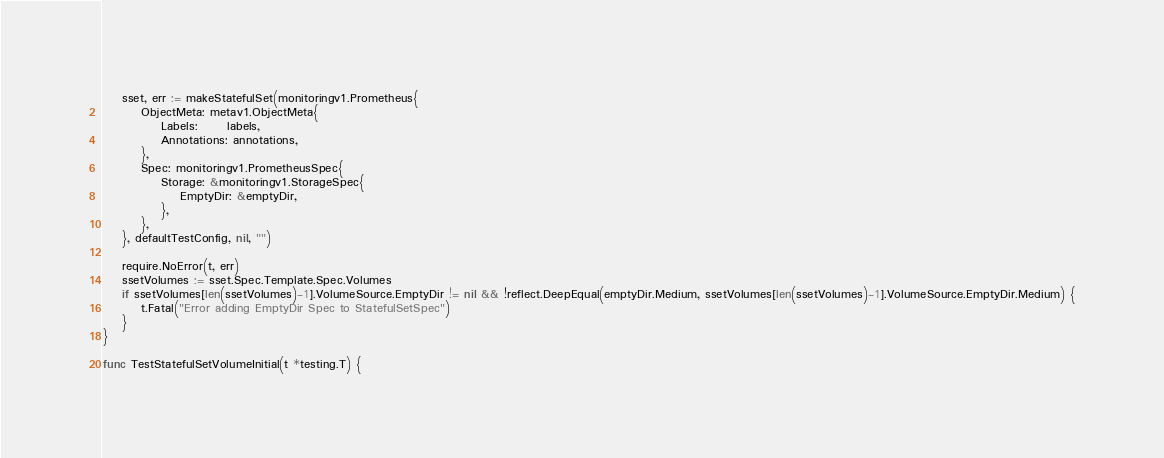Convert code to text. <code><loc_0><loc_0><loc_500><loc_500><_Go_>	sset, err := makeStatefulSet(monitoringv1.Prometheus{
		ObjectMeta: metav1.ObjectMeta{
			Labels:      labels,
			Annotations: annotations,
		},
		Spec: monitoringv1.PrometheusSpec{
			Storage: &monitoringv1.StorageSpec{
				EmptyDir: &emptyDir,
			},
		},
	}, defaultTestConfig, nil, "")

	require.NoError(t, err)
	ssetVolumes := sset.Spec.Template.Spec.Volumes
	if ssetVolumes[len(ssetVolumes)-1].VolumeSource.EmptyDir != nil && !reflect.DeepEqual(emptyDir.Medium, ssetVolumes[len(ssetVolumes)-1].VolumeSource.EmptyDir.Medium) {
		t.Fatal("Error adding EmptyDir Spec to StatefulSetSpec")
	}
}

func TestStatefulSetVolumeInitial(t *testing.T) {</code> 